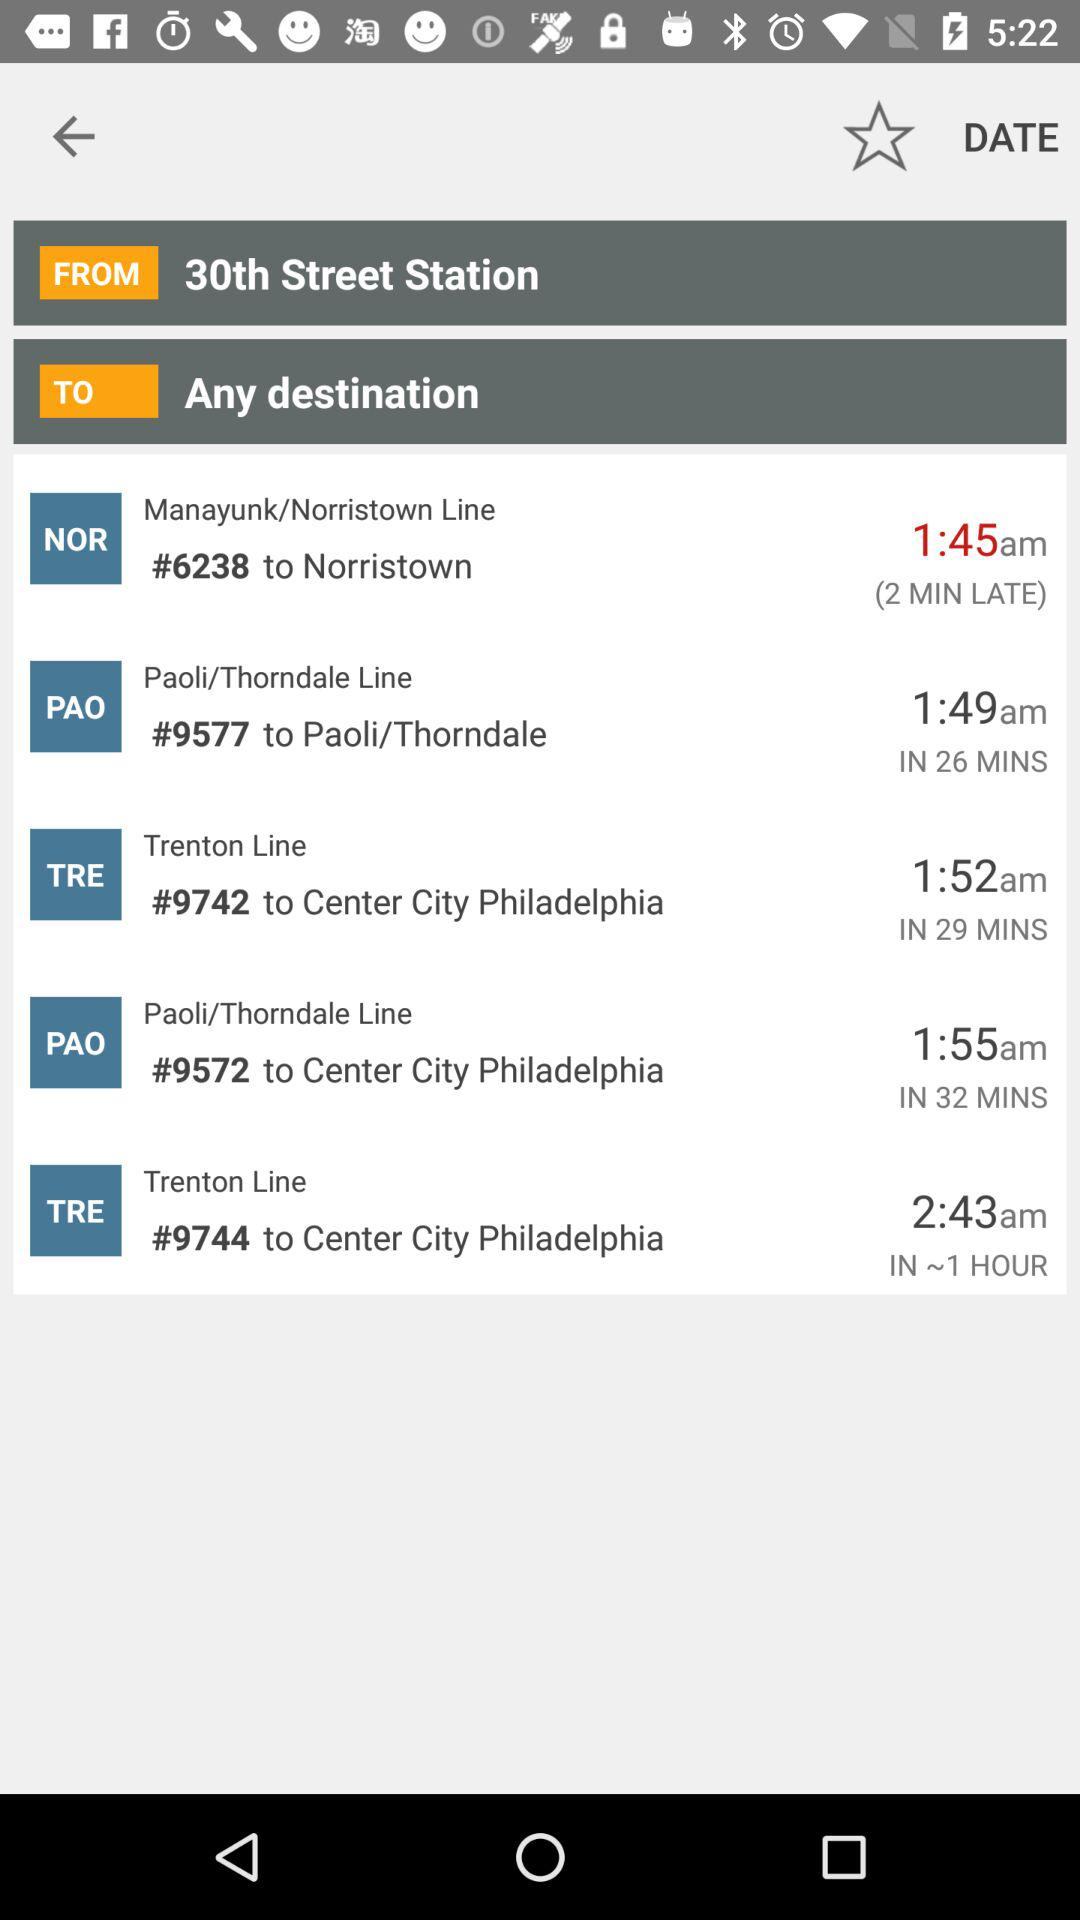What's the departure time of train #9742 going to Center City Philadelphia on the Trenton Line? The departure time of train #9742 going to Center City Philadelphia on the Trenton Line is 1:52 a.m. 